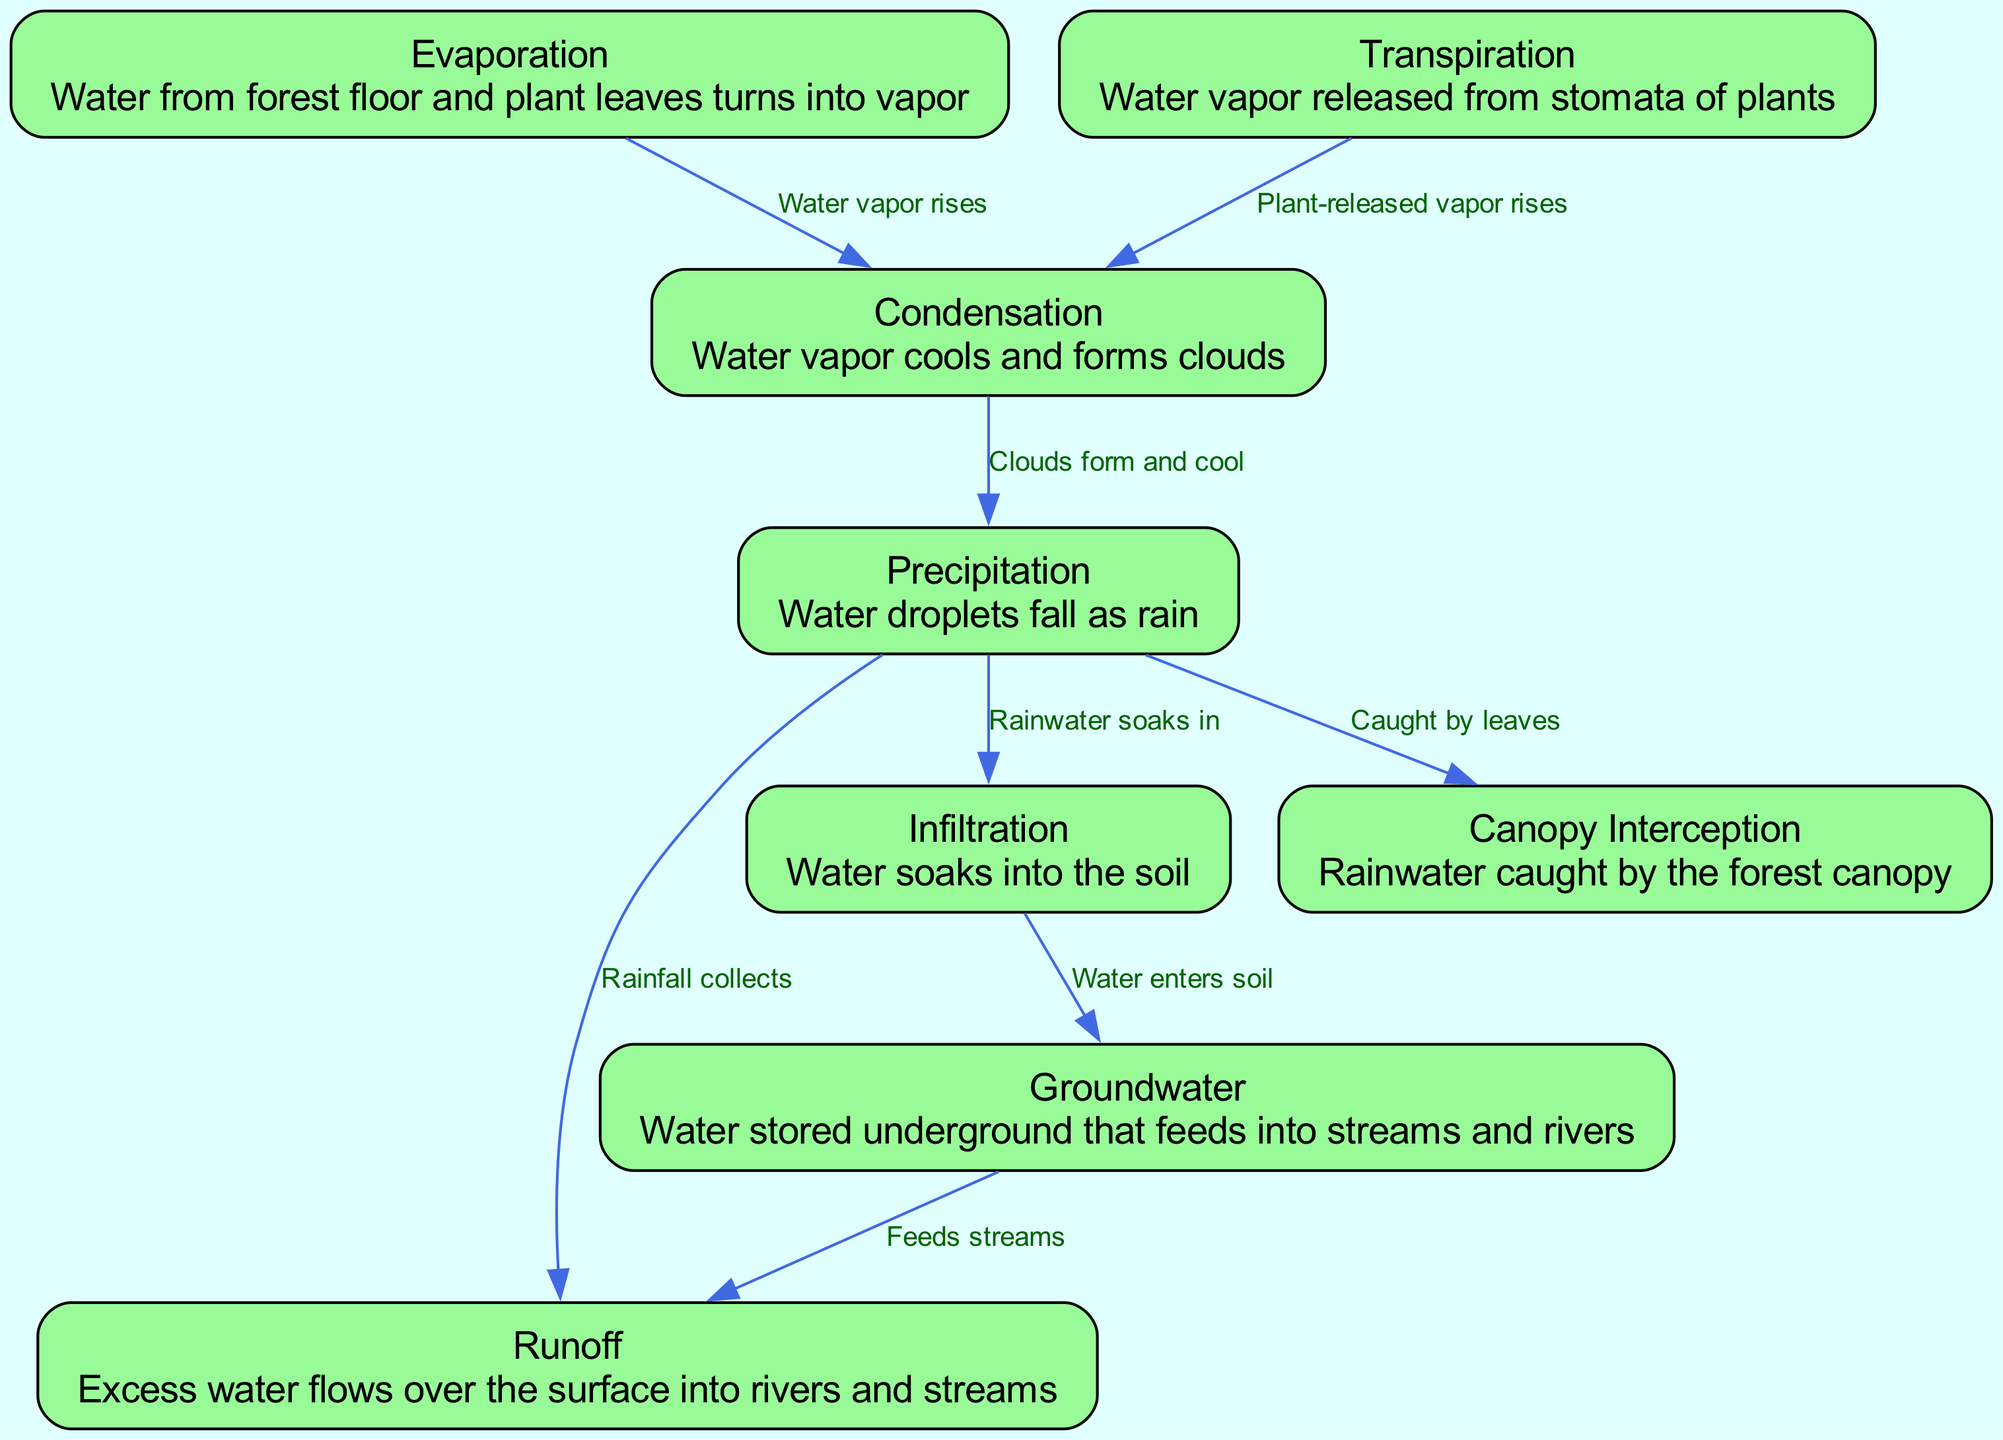What is the process by which water vapor is released from plants? The diagram identifies that water vapor released from the stomata of plants is called transpiration. This is directly stated in the description of the transpiration node.
Answer: Transpiration Which two processes contribute water vapor to the condensation process? According to the diagram, both evaporation and transpiration contribute water vapor that rises to form clouds. These relationships are illustrated with edges from both evaporation and transpiration to condensation.
Answer: Evaporation and Transpiration What happens after condensation in the water cycle? The diagram shows that after condensation, the process of precipitation occurs, where water droplets fall as rain. This relationship is illustrated with an edge leading from condensation to precipitation.
Answer: Precipitation How many processes are involved in this water cycle diagram? Counting the nodes in the diagram reveals there are eight distinct processes present, including evaporation, transpiration, condensation, precipitation, runoff, infiltration, canopy interception, and groundwater.
Answer: Eight What type of water movement is represented by the connection from infiltration to groundwater? The edge from infiltration to groundwater indicates that water enters the soil during infiltration and is stored underground as groundwater, as stated in the edge label.
Answer: Water enters soil 